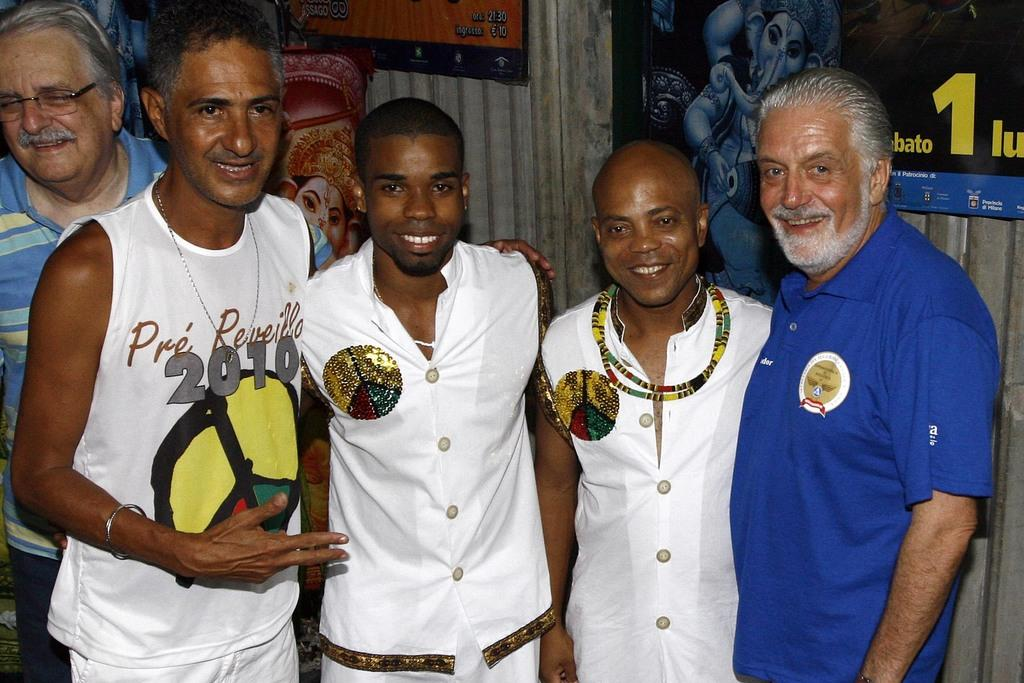What can be seen in the foreground of the picture? There are people standing in the foreground of the picture. Can you describe the men in the center of the image? There are three men wearing white dress in the center of the image. What is present in the background of the image? There are posters attached to the wall in the background of the image. What type of zinc is present in the image? There is no zinc present in the image. Can you describe the neck of the thing in the center of the image? There is no "thing" in the center of the image; it is three men wearing white dress. 